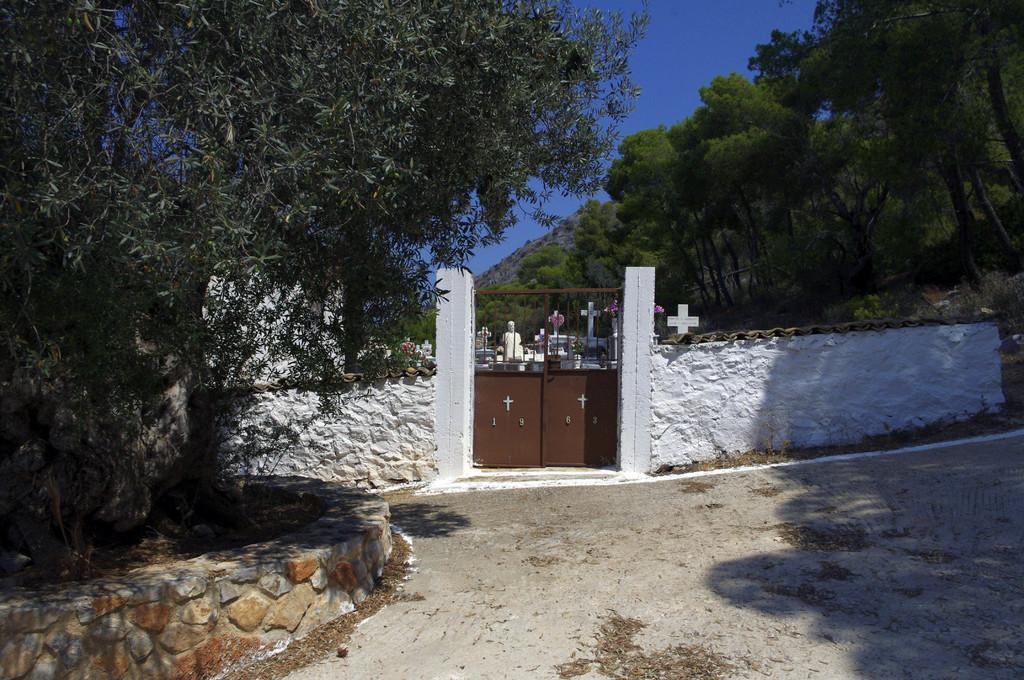Describe this image in one or two sentences. In the image we can see the compound, white in color and this is a gate. This is a footpath, stone wall, trees, cross symbol, sculpture and a blue sky. 